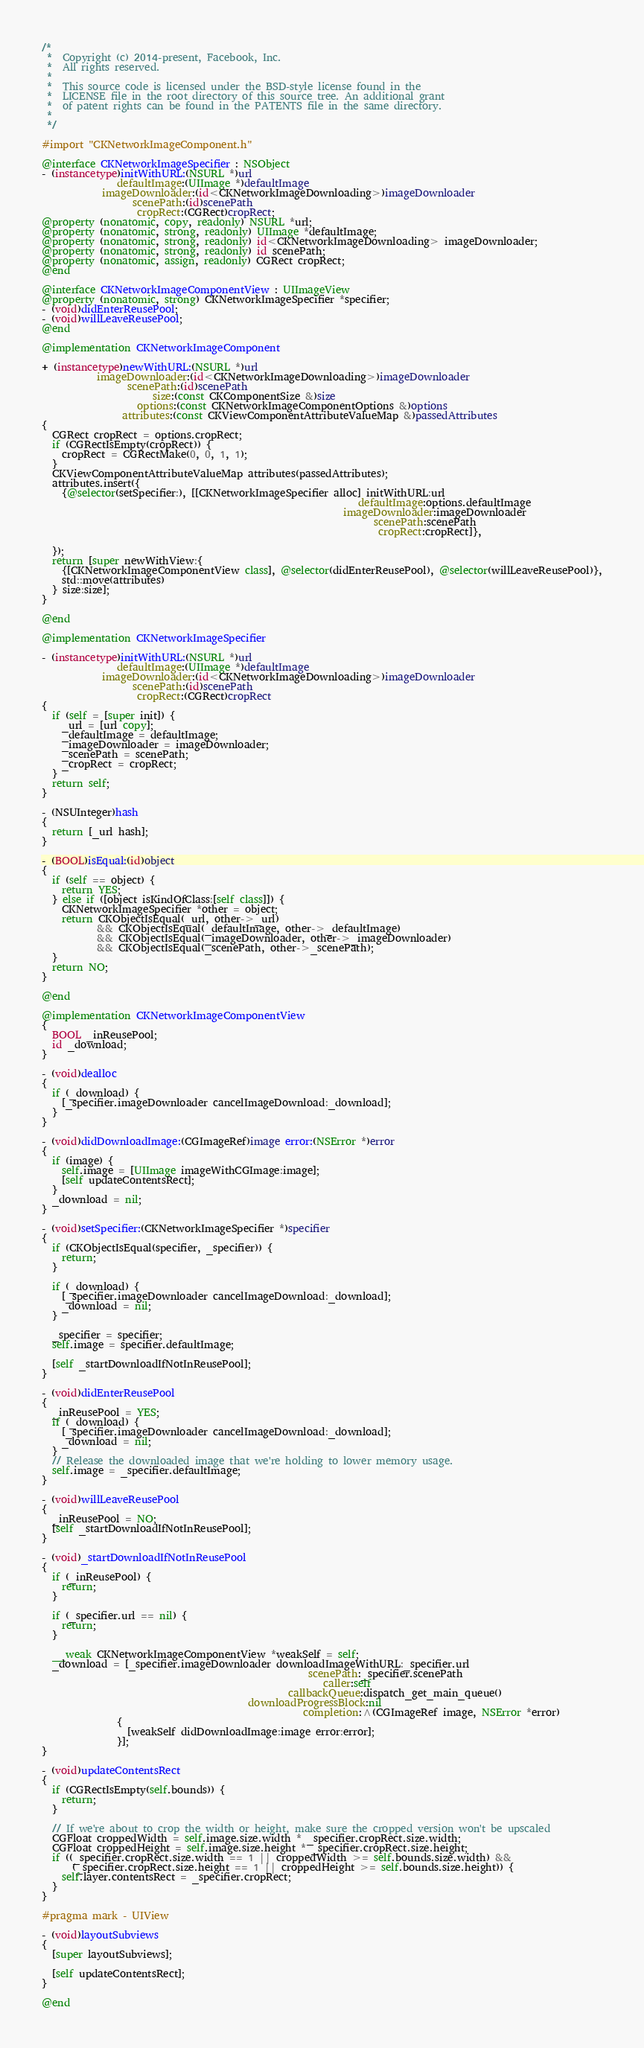Convert code to text. <code><loc_0><loc_0><loc_500><loc_500><_ObjectiveC_>/*
 *  Copyright (c) 2014-present, Facebook, Inc.
 *  All rights reserved.
 *
 *  This source code is licensed under the BSD-style license found in the
 *  LICENSE file in the root directory of this source tree. An additional grant
 *  of patent rights can be found in the PATENTS file in the same directory.
 *
 */

#import "CKNetworkImageComponent.h"

@interface CKNetworkImageSpecifier : NSObject
- (instancetype)initWithURL:(NSURL *)url
               defaultImage:(UIImage *)defaultImage
            imageDownloader:(id<CKNetworkImageDownloading>)imageDownloader
                  scenePath:(id)scenePath
                   cropRect:(CGRect)cropRect;
@property (nonatomic, copy, readonly) NSURL *url;
@property (nonatomic, strong, readonly) UIImage *defaultImage;
@property (nonatomic, strong, readonly) id<CKNetworkImageDownloading> imageDownloader;
@property (nonatomic, strong, readonly) id scenePath;
@property (nonatomic, assign, readonly) CGRect cropRect;
@end

@interface CKNetworkImageComponentView : UIImageView
@property (nonatomic, strong) CKNetworkImageSpecifier *specifier;
- (void)didEnterReusePool;
- (void)willLeaveReusePool;
@end

@implementation CKNetworkImageComponent

+ (instancetype)newWithURL:(NSURL *)url
           imageDownloader:(id<CKNetworkImageDownloading>)imageDownloader
                 scenePath:(id)scenePath
                      size:(const CKComponentSize &)size
                   options:(const CKNetworkImageComponentOptions &)options
                attributes:(const CKViewComponentAttributeValueMap &)passedAttributes
{
  CGRect cropRect = options.cropRect;
  if (CGRectIsEmpty(cropRect)) {
    cropRect = CGRectMake(0, 0, 1, 1);
  }
  CKViewComponentAttributeValueMap attributes(passedAttributes);
  attributes.insert({
    {@selector(setSpecifier:), [[CKNetworkImageSpecifier alloc] initWithURL:url
                                                               defaultImage:options.defaultImage
                                                            imageDownloader:imageDownloader
                                                                  scenePath:scenePath
                                                                   cropRect:cropRect]},

  });
  return [super newWithView:{
    {[CKNetworkImageComponentView class], @selector(didEnterReusePool), @selector(willLeaveReusePool)},
    std::move(attributes)
  } size:size];
}

@end

@implementation CKNetworkImageSpecifier

- (instancetype)initWithURL:(NSURL *)url
               defaultImage:(UIImage *)defaultImage
            imageDownloader:(id<CKNetworkImageDownloading>)imageDownloader
                  scenePath:(id)scenePath
                   cropRect:(CGRect)cropRect
{
  if (self = [super init]) {
    _url = [url copy];
    _defaultImage = defaultImage;
    _imageDownloader = imageDownloader;
    _scenePath = scenePath;
    _cropRect = cropRect;
  }
  return self;
}

- (NSUInteger)hash
{
  return [_url hash];
}

- (BOOL)isEqual:(id)object
{
  if (self == object) {
    return YES;
  } else if ([object isKindOfClass:[self class]]) {
    CKNetworkImageSpecifier *other = object;
    return CKObjectIsEqual(_url, other->_url)
           && CKObjectIsEqual(_defaultImage, other->_defaultImage)
           && CKObjectIsEqual(_imageDownloader, other->_imageDownloader)
           && CKObjectIsEqual(_scenePath, other->_scenePath);
  }
  return NO;
}

@end

@implementation CKNetworkImageComponentView
{
  BOOL _inReusePool;
  id _download;
}

- (void)dealloc
{
  if (_download) {
    [_specifier.imageDownloader cancelImageDownload:_download];
  }
}

- (void)didDownloadImage:(CGImageRef)image error:(NSError *)error
{
  if (image) {
    self.image = [UIImage imageWithCGImage:image];
    [self updateContentsRect];
  }
  _download = nil;
}

- (void)setSpecifier:(CKNetworkImageSpecifier *)specifier
{
  if (CKObjectIsEqual(specifier, _specifier)) {
    return;
  }

  if (_download) {
    [_specifier.imageDownloader cancelImageDownload:_download];
    _download = nil;
  }

  _specifier = specifier;
  self.image = specifier.defaultImage;

  [self _startDownloadIfNotInReusePool];
}

- (void)didEnterReusePool
{
  _inReusePool = YES;
  if (_download) {
    [_specifier.imageDownloader cancelImageDownload:_download];
    _download = nil;
  }
  // Release the downloaded image that we're holding to lower memory usage.
  self.image = _specifier.defaultImage;
}

- (void)willLeaveReusePool
{
  _inReusePool = NO;
  [self _startDownloadIfNotInReusePool];
}

- (void)_startDownloadIfNotInReusePool
{
  if (_inReusePool) {
    return;
  }

  if (_specifier.url == nil) {
    return;
  }

  __weak CKNetworkImageComponentView *weakSelf = self;
  _download = [_specifier.imageDownloader downloadImageWithURL:_specifier.url
                                                     scenePath:_specifier.scenePath
                                                        caller:self
                                                 callbackQueue:dispatch_get_main_queue()
                                         downloadProgressBlock:nil
                                                    completion:^(CGImageRef image, NSError *error)
               {
                 [weakSelf didDownloadImage:image error:error];
               }];
}

- (void)updateContentsRect
{
  if (CGRectIsEmpty(self.bounds)) {
    return;
  }

  // If we're about to crop the width or height, make sure the cropped version won't be upscaled
  CGFloat croppedWidth = self.image.size.width * _specifier.cropRect.size.width;
  CGFloat croppedHeight = self.image.size.height * _specifier.cropRect.size.height;
  if ((_specifier.cropRect.size.width == 1 || croppedWidth >= self.bounds.size.width) &&
      (_specifier.cropRect.size.height == 1 || croppedHeight >= self.bounds.size.height)) {
    self.layer.contentsRect = _specifier.cropRect;
  }
}

#pragma mark - UIView

- (void)layoutSubviews
{
  [super layoutSubviews];

  [self updateContentsRect];
}

@end
</code> 